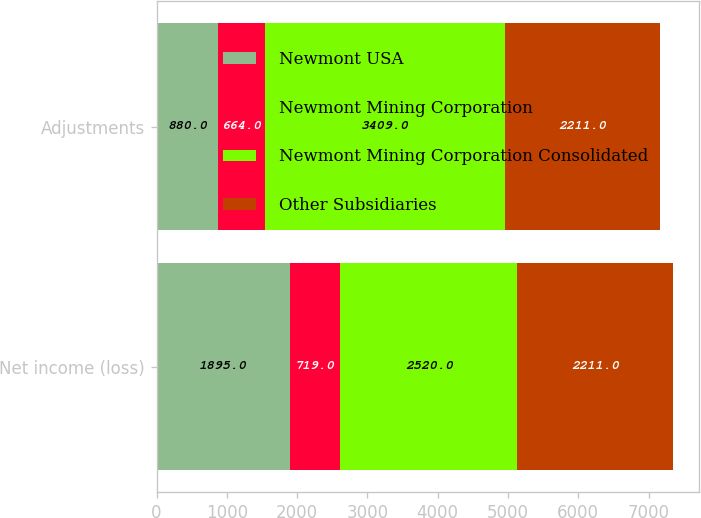Convert chart to OTSL. <chart><loc_0><loc_0><loc_500><loc_500><stacked_bar_chart><ecel><fcel>Net income (loss)<fcel>Adjustments<nl><fcel>Newmont USA<fcel>1895<fcel>880<nl><fcel>Newmont Mining Corporation<fcel>719<fcel>664<nl><fcel>Newmont Mining Corporation Consolidated<fcel>2520<fcel>3409<nl><fcel>Other Subsidiaries<fcel>2211<fcel>2211<nl></chart> 